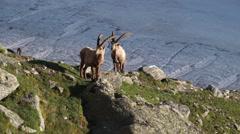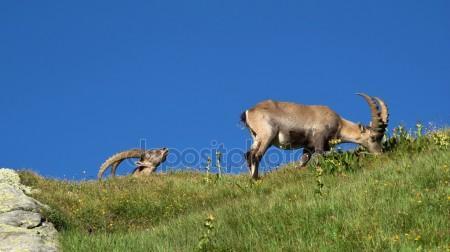The first image is the image on the left, the second image is the image on the right. For the images displayed, is the sentence "There are exactly four mountain goats total." factually correct? Answer yes or no. Yes. The first image is the image on the left, the second image is the image on the right. Given the left and right images, does the statement "One image shows exactly one adult horned animal near at least one juvenile animal with no more than tiny horns." hold true? Answer yes or no. No. 